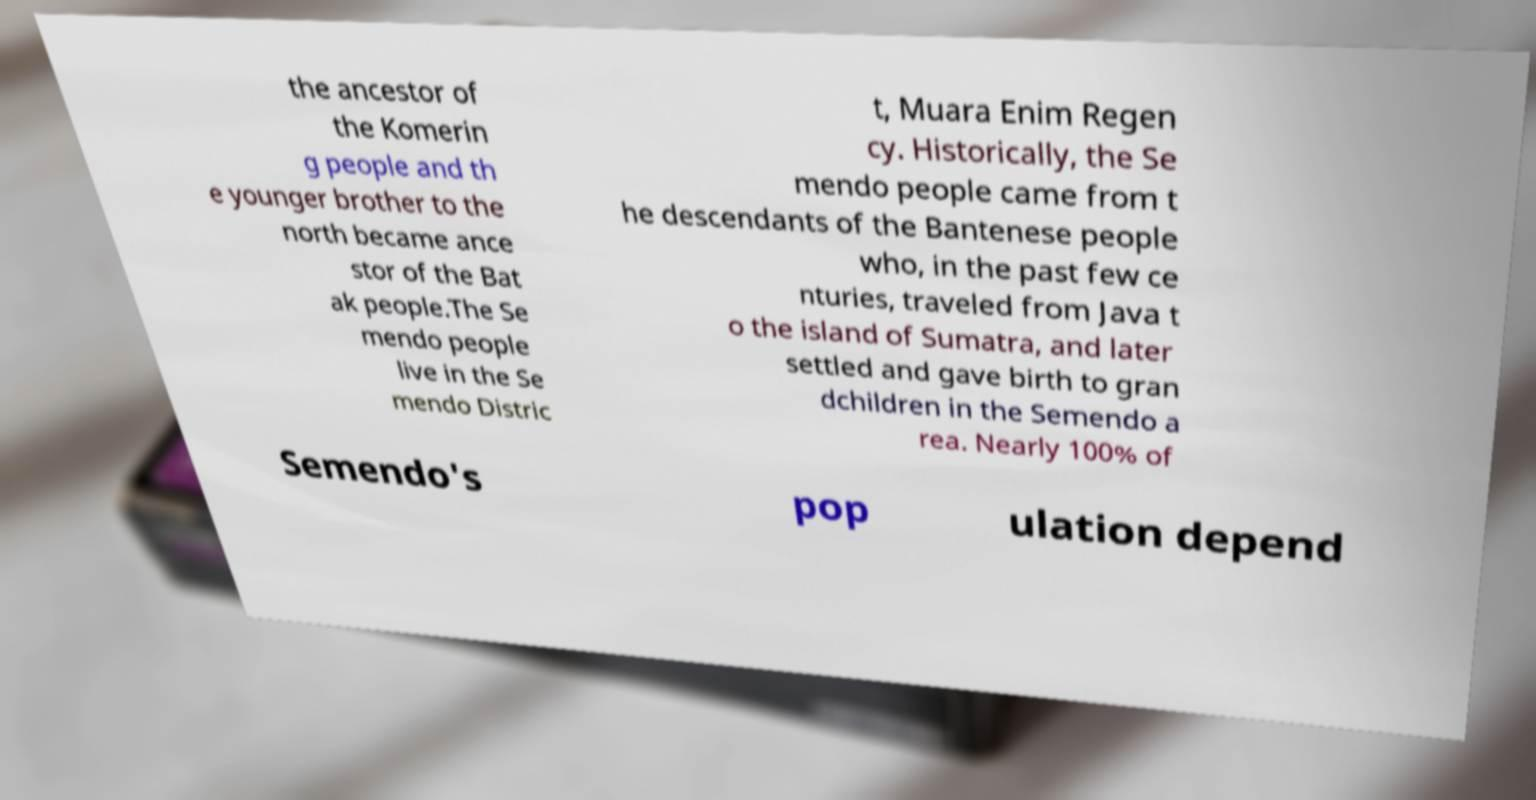Can you accurately transcribe the text from the provided image for me? the ancestor of the Komerin g people and th e younger brother to the north became ance stor of the Bat ak people.The Se mendo people live in the Se mendo Distric t, Muara Enim Regen cy. Historically, the Se mendo people came from t he descendants of the Bantenese people who, in the past few ce nturies, traveled from Java t o the island of Sumatra, and later settled and gave birth to gran dchildren in the Semendo a rea. Nearly 100% of Semendo's pop ulation depend 